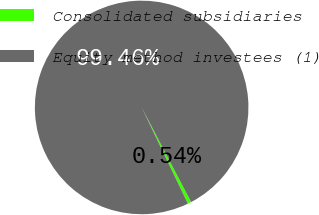<chart> <loc_0><loc_0><loc_500><loc_500><pie_chart><fcel>Consolidated subsidiaries<fcel>Equity method investees (1)<nl><fcel>0.54%<fcel>99.46%<nl></chart> 